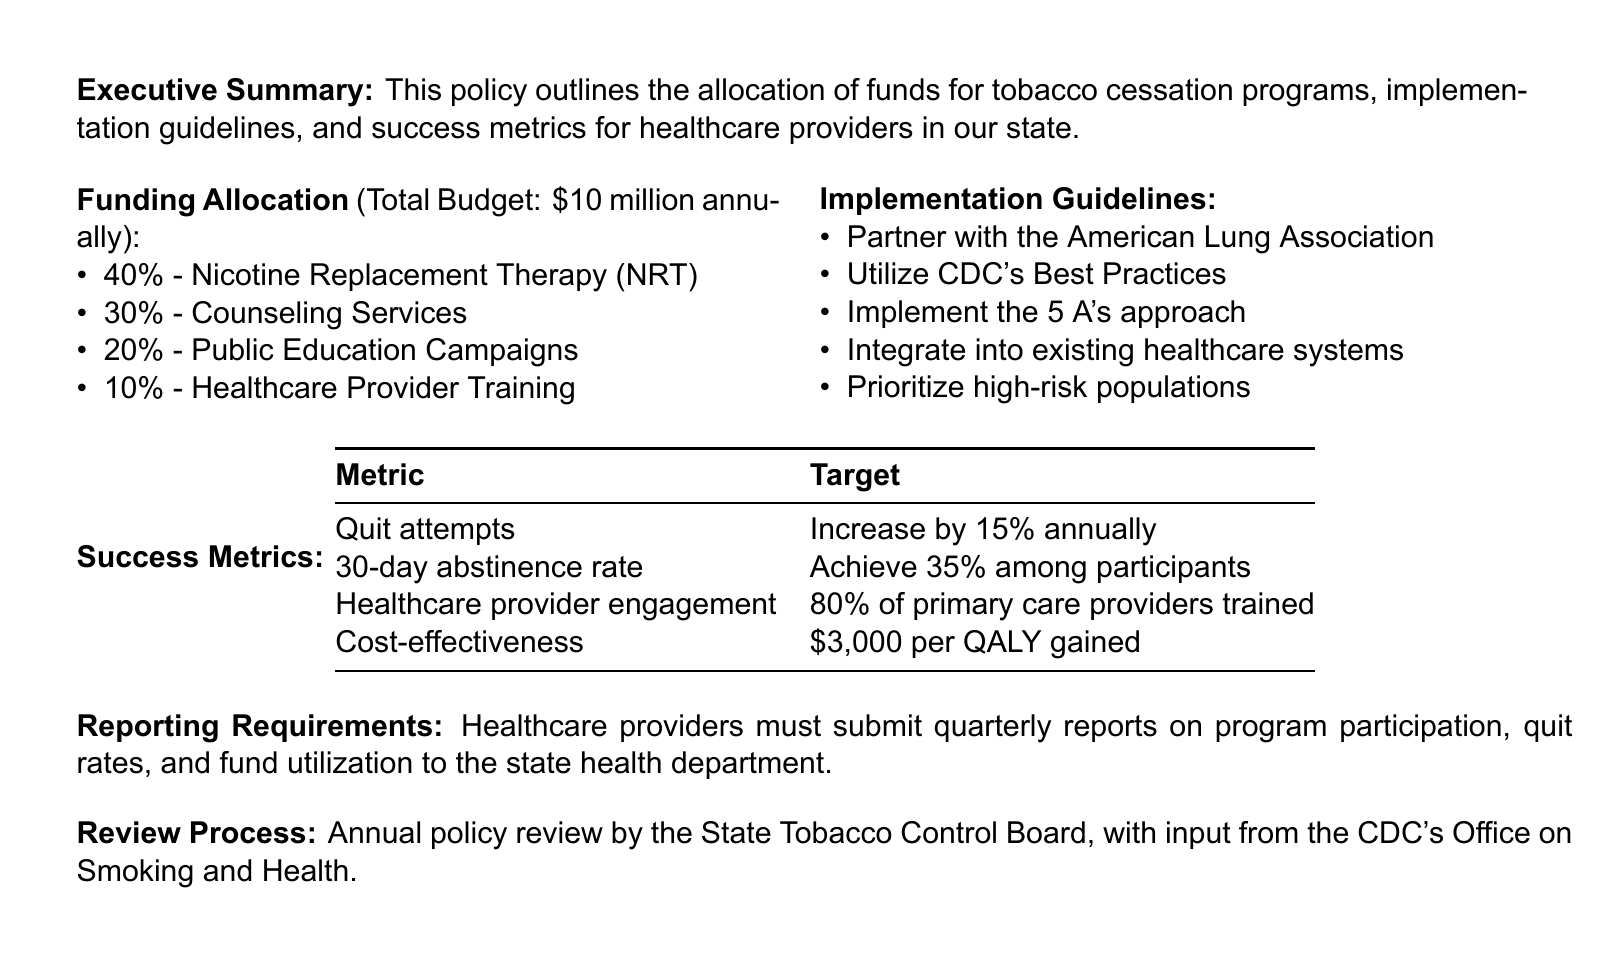What is the annual total budget for the tobacco cessation program? The total budget is stated in the funding allocation section of the document.
Answer: $10 million What percentage of the budget is allocated to nicotine replacement therapy? The allocation for nicotine replacement therapy is explicitly mentioned in the funding allocation section.
Answer: 40% What is one of the implementation guidelines listed in the document? The implementation guidelines include specific actions healthcare providers should take.
Answer: Partner with the American Lung Association What is the target percentage for 30-day abstinence rates among participants? The target for 30-day abstinence is provided in the success metrics section.
Answer: 35% How often must healthcare providers submit reports on program participation? The reporting requirements section outlines the frequency of reporting.
Answer: Quarterly What is the target increase in quit attempts annually? The document specifies the target increase for quit attempts in the success metrics section.
Answer: 15% What is one metric for cost-effectiveness mentioned in the document? The success metrics include cost-effectiveness as part of the evaluation.
Answer: $3,000 per QALY gained Who conducts the annual review of the policy? The review process section states who is responsible for the annual policy review.
Answer: State Tobacco Control Board 